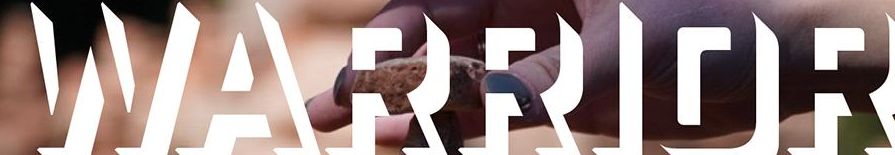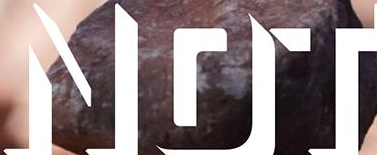What text appears in these images from left to right, separated by a semicolon? WARRIOR; NOT 